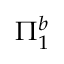Convert formula to latex. <formula><loc_0><loc_0><loc_500><loc_500>\Pi _ { 1 } ^ { b }</formula> 